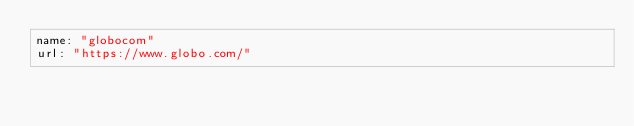Convert code to text. <code><loc_0><loc_0><loc_500><loc_500><_YAML_>name: "globocom"
url: "https://www.globo.com/"
</code> 